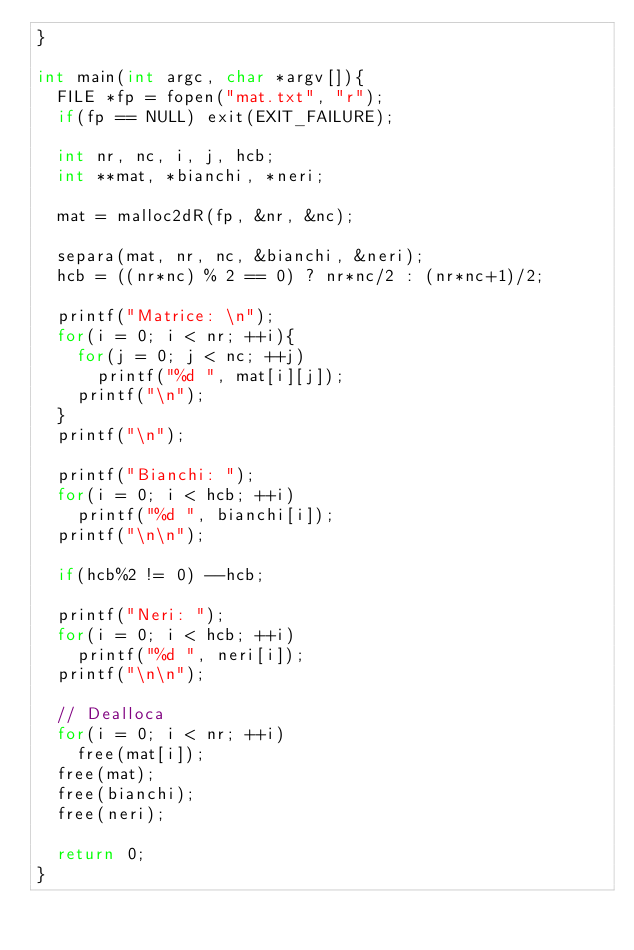Convert code to text. <code><loc_0><loc_0><loc_500><loc_500><_C_>}

int main(int argc, char *argv[]){
	FILE *fp = fopen("mat.txt", "r");
	if(fp == NULL) exit(EXIT_FAILURE);

	int nr, nc, i, j, hcb;
	int **mat, *bianchi, *neri;

	mat = malloc2dR(fp, &nr, &nc);

	separa(mat, nr, nc, &bianchi, &neri);
	hcb = ((nr*nc) % 2 == 0) ? nr*nc/2 : (nr*nc+1)/2;
	
	printf("Matrice: \n");
	for(i = 0; i < nr; ++i){
		for(j = 0; j < nc; ++j)
			printf("%d ", mat[i][j]);
		printf("\n");
	}
	printf("\n");

	printf("Bianchi: ");
	for(i = 0; i < hcb; ++i)
		printf("%d ", bianchi[i]);
	printf("\n\n");

	if(hcb%2 != 0) --hcb;
	
	printf("Neri: ");
	for(i = 0; i < hcb; ++i)
		printf("%d ", neri[i]);
	printf("\n\n");

	// Dealloca
	for(i = 0; i < nr; ++i)
		free(mat[i]);
	free(mat);
	free(bianchi);
	free(neri);

	return 0;
}
</code> 